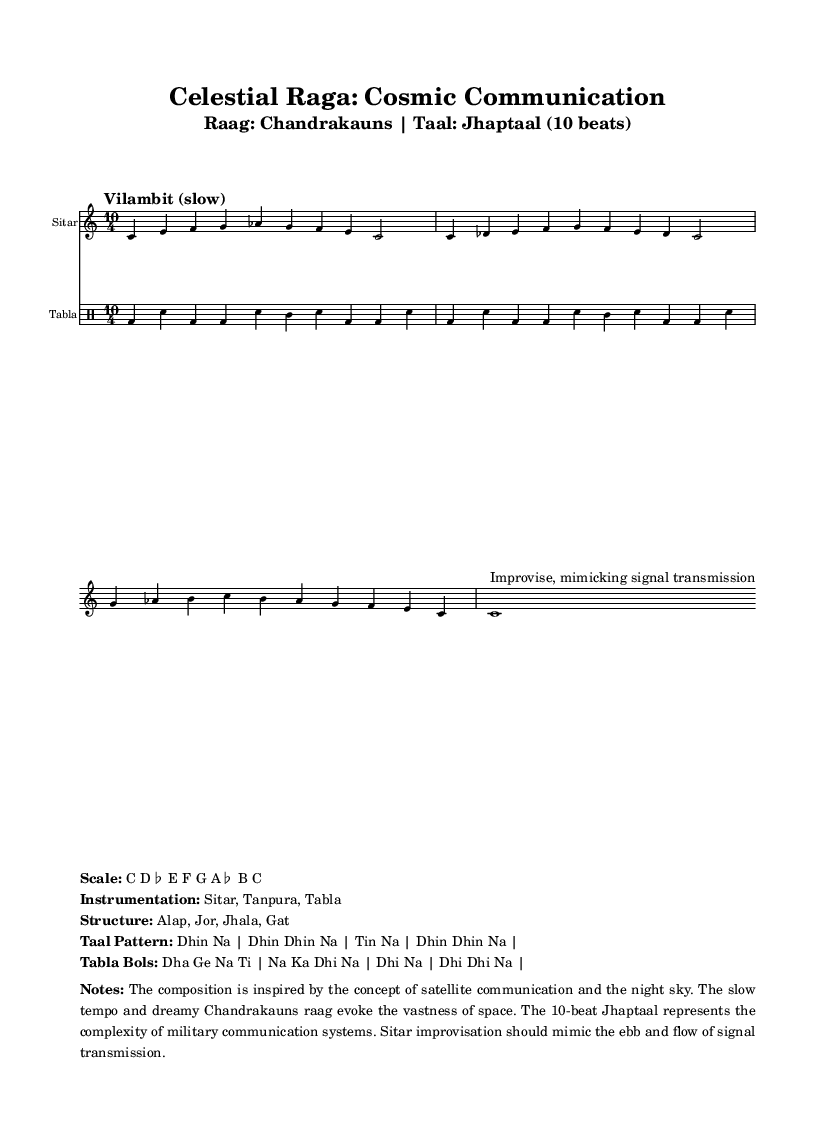What is the key signature of this music? The key signature is indicated as C major, which has no sharps or flats. The note C is prominent, and there are no accidentals in the scale descriptor.
Answer: C major What is the time signature of the piece? The time signature is shown as 10/4, indicating there are ten beats in each measure, which suggests a complex rhythmic structure appropriate for Jhaptaal.
Answer: 10/4 What is the tempo marking for the performance? The tempo marking is "Vilambit (slow)," which instructs the performer to play at a slow tempo, enhancing the dreamy quality of the raga.
Answer: Vilambit (slow) What is the scale used in this composition? The scale used is C D flat E F G A flat B C, which reflects the unique interval structure of the Chandrakauns raga and its associations with the night sky.
Answer: C D flat E F G A flat B C How many beats are there in the Jhaptaal cycle? Jhaptaal is specified to consist of 10 beats in total, making it distinctive among traditional rhythms and symbolizing the complexity of communication systems.
Answer: 10 What instrumentation is utilized in this piece? The instrumentation includes the Sitar, Tanpura, and Tabla, each contributing to the overall texture and character of the performance, central to Indian classical music.
Answer: Sitar, Tanpura, Tabla What should the sitar improvisation mimic in this piece? The sitar improvisation is intended to mimic the ebb and flow of signal transmission, suggesting a connection to the theme of satellite communication through musical expression.
Answer: Signal transmission 